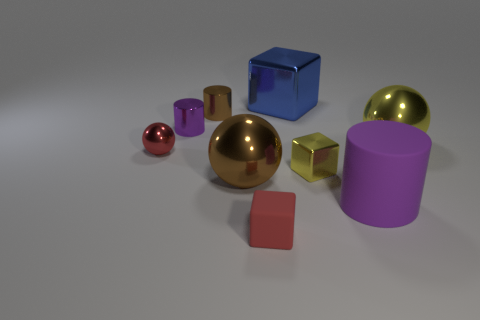What number of red balls have the same size as the matte cube?
Your answer should be very brief. 1. Does the tiny red shiny object have the same shape as the blue object?
Offer a terse response. No. What is the color of the big sphere right of the metal cube that is in front of the purple metal object?
Your answer should be very brief. Yellow. How big is the object that is both right of the big blue object and in front of the large brown thing?
Provide a succinct answer. Large. Are there any other things of the same color as the tiny shiny sphere?
Give a very brief answer. Yes. What is the shape of the small red object that is the same material as the big brown thing?
Keep it short and to the point. Sphere. Do the big rubber object and the large metal thing that is behind the large yellow ball have the same shape?
Keep it short and to the point. No. The sphere that is left of the big ball that is to the left of the big blue object is made of what material?
Offer a terse response. Metal. Is the number of large cylinders that are in front of the tiny purple metal thing the same as the number of small shiny cylinders?
Ensure brevity in your answer.  No. There is a small cube to the left of the blue thing; is its color the same as the metal sphere to the left of the large brown metallic ball?
Provide a succinct answer. Yes. 